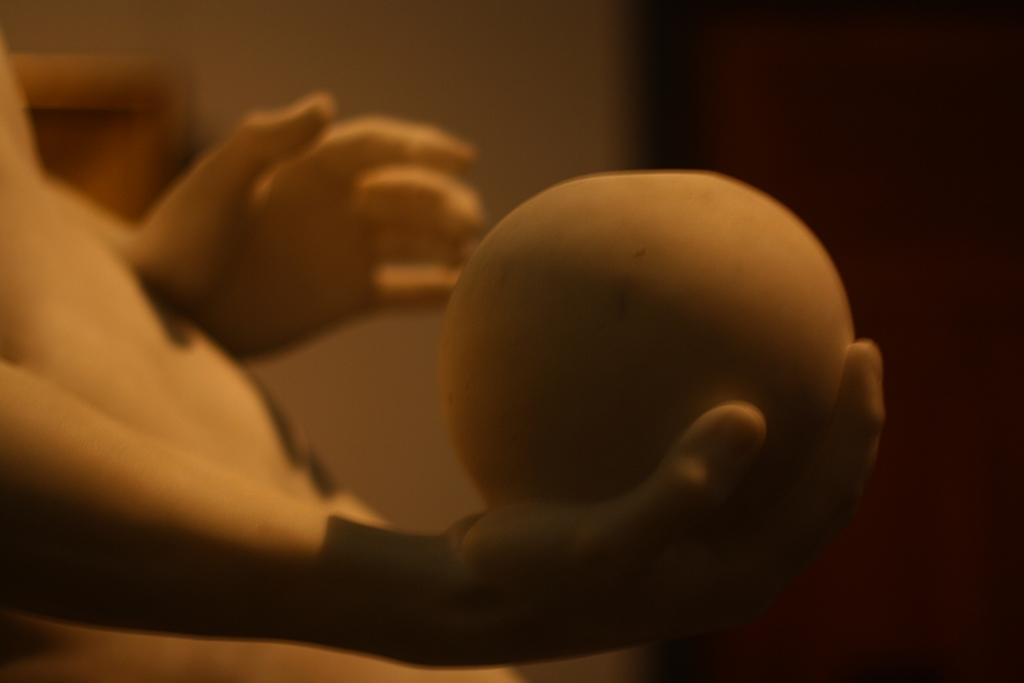What is the main subject of the image? There is a statue of a person in the image. What is the person holding in the statue? The person is holding a round object. Can you describe the background of the image? The background of the image is blurry. How many baby corn plants can be seen growing near the statue in the image? There is no mention of baby corn plants or any plants in the image; it only features a statue of a person holding a round object with a blurry background. 